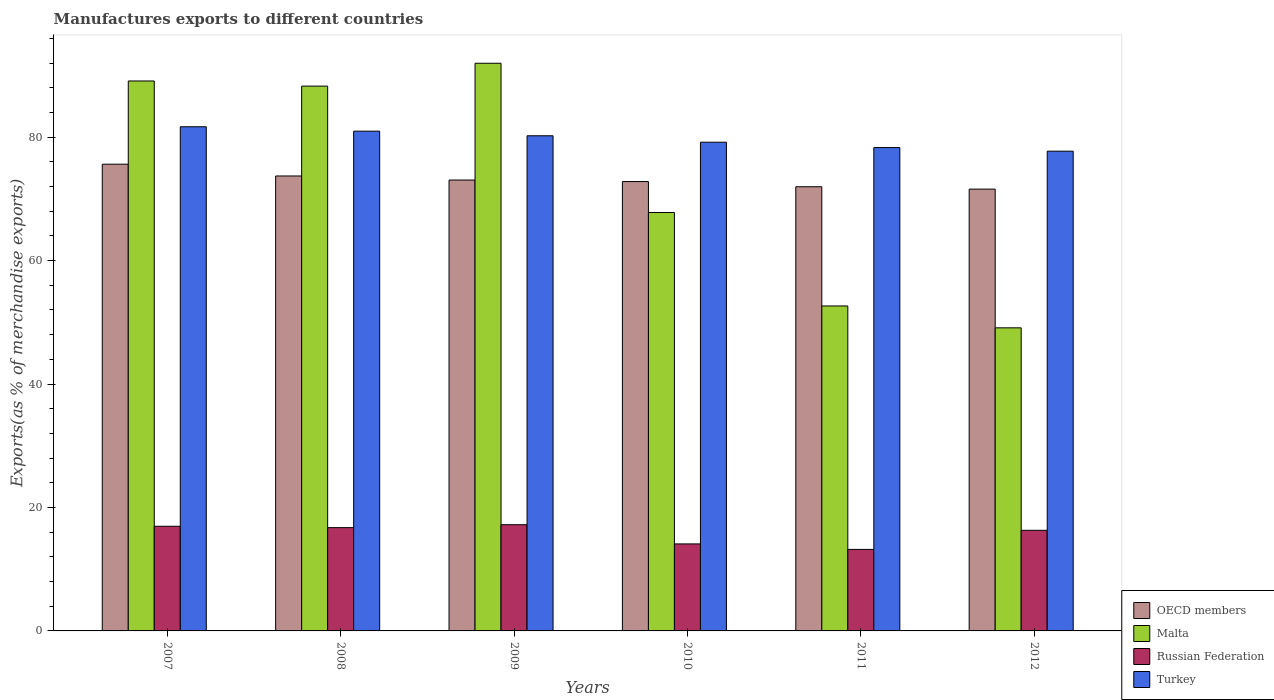How many different coloured bars are there?
Your answer should be very brief. 4. How many bars are there on the 5th tick from the left?
Ensure brevity in your answer.  4. How many bars are there on the 3rd tick from the right?
Provide a short and direct response. 4. In how many cases, is the number of bars for a given year not equal to the number of legend labels?
Provide a succinct answer. 0. What is the percentage of exports to different countries in Malta in 2007?
Ensure brevity in your answer.  89.1. Across all years, what is the maximum percentage of exports to different countries in OECD members?
Offer a very short reply. 75.62. Across all years, what is the minimum percentage of exports to different countries in Russian Federation?
Ensure brevity in your answer.  13.21. In which year was the percentage of exports to different countries in OECD members maximum?
Provide a succinct answer. 2007. In which year was the percentage of exports to different countries in Turkey minimum?
Your response must be concise. 2012. What is the total percentage of exports to different countries in Turkey in the graph?
Make the answer very short. 478.11. What is the difference between the percentage of exports to different countries in Malta in 2008 and that in 2012?
Keep it short and to the point. 39.16. What is the difference between the percentage of exports to different countries in Turkey in 2010 and the percentage of exports to different countries in OECD members in 2009?
Offer a very short reply. 6.13. What is the average percentage of exports to different countries in OECD members per year?
Offer a terse response. 73.12. In the year 2009, what is the difference between the percentage of exports to different countries in Turkey and percentage of exports to different countries in Malta?
Provide a succinct answer. -11.75. What is the ratio of the percentage of exports to different countries in Turkey in 2010 to that in 2012?
Provide a succinct answer. 1.02. Is the percentage of exports to different countries in OECD members in 2010 less than that in 2012?
Give a very brief answer. No. What is the difference between the highest and the second highest percentage of exports to different countries in Russian Federation?
Give a very brief answer. 0.25. What is the difference between the highest and the lowest percentage of exports to different countries in Malta?
Provide a succinct answer. 42.87. In how many years, is the percentage of exports to different countries in Turkey greater than the average percentage of exports to different countries in Turkey taken over all years?
Your response must be concise. 3. Is it the case that in every year, the sum of the percentage of exports to different countries in Turkey and percentage of exports to different countries in Russian Federation is greater than the sum of percentage of exports to different countries in OECD members and percentage of exports to different countries in Malta?
Offer a terse response. No. What does the 4th bar from the left in 2007 represents?
Keep it short and to the point. Turkey. What does the 3rd bar from the right in 2012 represents?
Provide a succinct answer. Malta. Is it the case that in every year, the sum of the percentage of exports to different countries in OECD members and percentage of exports to different countries in Turkey is greater than the percentage of exports to different countries in Malta?
Give a very brief answer. Yes. How many bars are there?
Your answer should be compact. 24. How many years are there in the graph?
Your answer should be very brief. 6. Where does the legend appear in the graph?
Your response must be concise. Bottom right. What is the title of the graph?
Your answer should be compact. Manufactures exports to different countries. Does "Rwanda" appear as one of the legend labels in the graph?
Your answer should be compact. No. What is the label or title of the Y-axis?
Give a very brief answer. Exports(as % of merchandise exports). What is the Exports(as % of merchandise exports) in OECD members in 2007?
Give a very brief answer. 75.62. What is the Exports(as % of merchandise exports) in Malta in 2007?
Provide a short and direct response. 89.1. What is the Exports(as % of merchandise exports) of Russian Federation in 2007?
Offer a terse response. 16.96. What is the Exports(as % of merchandise exports) of Turkey in 2007?
Make the answer very short. 81.69. What is the Exports(as % of merchandise exports) in OECD members in 2008?
Offer a very short reply. 73.71. What is the Exports(as % of merchandise exports) of Malta in 2008?
Your response must be concise. 88.27. What is the Exports(as % of merchandise exports) in Russian Federation in 2008?
Your answer should be compact. 16.74. What is the Exports(as % of merchandise exports) in Turkey in 2008?
Ensure brevity in your answer.  80.97. What is the Exports(as % of merchandise exports) of OECD members in 2009?
Offer a terse response. 73.06. What is the Exports(as % of merchandise exports) of Malta in 2009?
Make the answer very short. 91.98. What is the Exports(as % of merchandise exports) of Russian Federation in 2009?
Keep it short and to the point. 17.21. What is the Exports(as % of merchandise exports) in Turkey in 2009?
Provide a short and direct response. 80.23. What is the Exports(as % of merchandise exports) of OECD members in 2010?
Give a very brief answer. 72.81. What is the Exports(as % of merchandise exports) in Malta in 2010?
Your answer should be very brief. 67.79. What is the Exports(as % of merchandise exports) in Russian Federation in 2010?
Your answer should be very brief. 14.1. What is the Exports(as % of merchandise exports) of Turkey in 2010?
Your answer should be compact. 79.18. What is the Exports(as % of merchandise exports) of OECD members in 2011?
Keep it short and to the point. 71.97. What is the Exports(as % of merchandise exports) in Malta in 2011?
Provide a short and direct response. 52.65. What is the Exports(as % of merchandise exports) of Russian Federation in 2011?
Make the answer very short. 13.21. What is the Exports(as % of merchandise exports) in Turkey in 2011?
Keep it short and to the point. 78.31. What is the Exports(as % of merchandise exports) of OECD members in 2012?
Your response must be concise. 71.58. What is the Exports(as % of merchandise exports) of Malta in 2012?
Provide a short and direct response. 49.11. What is the Exports(as % of merchandise exports) of Russian Federation in 2012?
Keep it short and to the point. 16.3. What is the Exports(as % of merchandise exports) in Turkey in 2012?
Make the answer very short. 77.73. Across all years, what is the maximum Exports(as % of merchandise exports) in OECD members?
Make the answer very short. 75.62. Across all years, what is the maximum Exports(as % of merchandise exports) of Malta?
Provide a succinct answer. 91.98. Across all years, what is the maximum Exports(as % of merchandise exports) of Russian Federation?
Make the answer very short. 17.21. Across all years, what is the maximum Exports(as % of merchandise exports) of Turkey?
Make the answer very short. 81.69. Across all years, what is the minimum Exports(as % of merchandise exports) in OECD members?
Your answer should be compact. 71.58. Across all years, what is the minimum Exports(as % of merchandise exports) of Malta?
Keep it short and to the point. 49.11. Across all years, what is the minimum Exports(as % of merchandise exports) in Russian Federation?
Give a very brief answer. 13.21. Across all years, what is the minimum Exports(as % of merchandise exports) in Turkey?
Ensure brevity in your answer.  77.73. What is the total Exports(as % of merchandise exports) of OECD members in the graph?
Your answer should be very brief. 438.75. What is the total Exports(as % of merchandise exports) of Malta in the graph?
Offer a very short reply. 438.91. What is the total Exports(as % of merchandise exports) of Russian Federation in the graph?
Offer a very short reply. 94.51. What is the total Exports(as % of merchandise exports) in Turkey in the graph?
Keep it short and to the point. 478.11. What is the difference between the Exports(as % of merchandise exports) of OECD members in 2007 and that in 2008?
Your answer should be compact. 1.91. What is the difference between the Exports(as % of merchandise exports) in Malta in 2007 and that in 2008?
Ensure brevity in your answer.  0.83. What is the difference between the Exports(as % of merchandise exports) of Russian Federation in 2007 and that in 2008?
Your response must be concise. 0.22. What is the difference between the Exports(as % of merchandise exports) in Turkey in 2007 and that in 2008?
Your answer should be compact. 0.71. What is the difference between the Exports(as % of merchandise exports) in OECD members in 2007 and that in 2009?
Provide a succinct answer. 2.57. What is the difference between the Exports(as % of merchandise exports) of Malta in 2007 and that in 2009?
Offer a terse response. -2.87. What is the difference between the Exports(as % of merchandise exports) in Russian Federation in 2007 and that in 2009?
Keep it short and to the point. -0.25. What is the difference between the Exports(as % of merchandise exports) of Turkey in 2007 and that in 2009?
Make the answer very short. 1.46. What is the difference between the Exports(as % of merchandise exports) in OECD members in 2007 and that in 2010?
Make the answer very short. 2.81. What is the difference between the Exports(as % of merchandise exports) of Malta in 2007 and that in 2010?
Make the answer very short. 21.31. What is the difference between the Exports(as % of merchandise exports) of Russian Federation in 2007 and that in 2010?
Your answer should be very brief. 2.86. What is the difference between the Exports(as % of merchandise exports) in Turkey in 2007 and that in 2010?
Give a very brief answer. 2.5. What is the difference between the Exports(as % of merchandise exports) of OECD members in 2007 and that in 2011?
Make the answer very short. 3.65. What is the difference between the Exports(as % of merchandise exports) of Malta in 2007 and that in 2011?
Ensure brevity in your answer.  36.45. What is the difference between the Exports(as % of merchandise exports) in Russian Federation in 2007 and that in 2011?
Ensure brevity in your answer.  3.75. What is the difference between the Exports(as % of merchandise exports) of Turkey in 2007 and that in 2011?
Your answer should be very brief. 3.37. What is the difference between the Exports(as % of merchandise exports) of OECD members in 2007 and that in 2012?
Keep it short and to the point. 4.04. What is the difference between the Exports(as % of merchandise exports) of Malta in 2007 and that in 2012?
Ensure brevity in your answer.  40. What is the difference between the Exports(as % of merchandise exports) in Russian Federation in 2007 and that in 2012?
Make the answer very short. 0.65. What is the difference between the Exports(as % of merchandise exports) in Turkey in 2007 and that in 2012?
Offer a terse response. 3.96. What is the difference between the Exports(as % of merchandise exports) of OECD members in 2008 and that in 2009?
Provide a succinct answer. 0.66. What is the difference between the Exports(as % of merchandise exports) in Malta in 2008 and that in 2009?
Make the answer very short. -3.7. What is the difference between the Exports(as % of merchandise exports) in Russian Federation in 2008 and that in 2009?
Offer a very short reply. -0.47. What is the difference between the Exports(as % of merchandise exports) in Turkey in 2008 and that in 2009?
Offer a terse response. 0.74. What is the difference between the Exports(as % of merchandise exports) of OECD members in 2008 and that in 2010?
Make the answer very short. 0.9. What is the difference between the Exports(as % of merchandise exports) in Malta in 2008 and that in 2010?
Make the answer very short. 20.48. What is the difference between the Exports(as % of merchandise exports) in Russian Federation in 2008 and that in 2010?
Your answer should be very brief. 2.64. What is the difference between the Exports(as % of merchandise exports) of Turkey in 2008 and that in 2010?
Give a very brief answer. 1.79. What is the difference between the Exports(as % of merchandise exports) of OECD members in 2008 and that in 2011?
Ensure brevity in your answer.  1.74. What is the difference between the Exports(as % of merchandise exports) of Malta in 2008 and that in 2011?
Your answer should be compact. 35.62. What is the difference between the Exports(as % of merchandise exports) in Russian Federation in 2008 and that in 2011?
Keep it short and to the point. 3.53. What is the difference between the Exports(as % of merchandise exports) in Turkey in 2008 and that in 2011?
Give a very brief answer. 2.66. What is the difference between the Exports(as % of merchandise exports) of OECD members in 2008 and that in 2012?
Your answer should be compact. 2.13. What is the difference between the Exports(as % of merchandise exports) in Malta in 2008 and that in 2012?
Make the answer very short. 39.16. What is the difference between the Exports(as % of merchandise exports) of Russian Federation in 2008 and that in 2012?
Keep it short and to the point. 0.43. What is the difference between the Exports(as % of merchandise exports) of Turkey in 2008 and that in 2012?
Provide a short and direct response. 3.24. What is the difference between the Exports(as % of merchandise exports) of OECD members in 2009 and that in 2010?
Your response must be concise. 0.25. What is the difference between the Exports(as % of merchandise exports) in Malta in 2009 and that in 2010?
Make the answer very short. 24.18. What is the difference between the Exports(as % of merchandise exports) in Russian Federation in 2009 and that in 2010?
Provide a short and direct response. 3.11. What is the difference between the Exports(as % of merchandise exports) of Turkey in 2009 and that in 2010?
Make the answer very short. 1.04. What is the difference between the Exports(as % of merchandise exports) in OECD members in 2009 and that in 2011?
Ensure brevity in your answer.  1.09. What is the difference between the Exports(as % of merchandise exports) in Malta in 2009 and that in 2011?
Provide a succinct answer. 39.32. What is the difference between the Exports(as % of merchandise exports) in Russian Federation in 2009 and that in 2011?
Your answer should be very brief. 4. What is the difference between the Exports(as % of merchandise exports) in Turkey in 2009 and that in 2011?
Keep it short and to the point. 1.91. What is the difference between the Exports(as % of merchandise exports) in OECD members in 2009 and that in 2012?
Offer a terse response. 1.47. What is the difference between the Exports(as % of merchandise exports) of Malta in 2009 and that in 2012?
Keep it short and to the point. 42.87. What is the difference between the Exports(as % of merchandise exports) of Russian Federation in 2009 and that in 2012?
Give a very brief answer. 0.91. What is the difference between the Exports(as % of merchandise exports) in Turkey in 2009 and that in 2012?
Provide a succinct answer. 2.5. What is the difference between the Exports(as % of merchandise exports) of OECD members in 2010 and that in 2011?
Keep it short and to the point. 0.84. What is the difference between the Exports(as % of merchandise exports) of Malta in 2010 and that in 2011?
Provide a succinct answer. 15.14. What is the difference between the Exports(as % of merchandise exports) of Russian Federation in 2010 and that in 2011?
Ensure brevity in your answer.  0.89. What is the difference between the Exports(as % of merchandise exports) in Turkey in 2010 and that in 2011?
Keep it short and to the point. 0.87. What is the difference between the Exports(as % of merchandise exports) of OECD members in 2010 and that in 2012?
Offer a terse response. 1.22. What is the difference between the Exports(as % of merchandise exports) of Malta in 2010 and that in 2012?
Your answer should be compact. 18.68. What is the difference between the Exports(as % of merchandise exports) in Russian Federation in 2010 and that in 2012?
Ensure brevity in your answer.  -2.2. What is the difference between the Exports(as % of merchandise exports) in Turkey in 2010 and that in 2012?
Ensure brevity in your answer.  1.45. What is the difference between the Exports(as % of merchandise exports) in OECD members in 2011 and that in 2012?
Your answer should be compact. 0.38. What is the difference between the Exports(as % of merchandise exports) in Malta in 2011 and that in 2012?
Your response must be concise. 3.54. What is the difference between the Exports(as % of merchandise exports) in Russian Federation in 2011 and that in 2012?
Give a very brief answer. -3.1. What is the difference between the Exports(as % of merchandise exports) in Turkey in 2011 and that in 2012?
Your answer should be compact. 0.58. What is the difference between the Exports(as % of merchandise exports) of OECD members in 2007 and the Exports(as % of merchandise exports) of Malta in 2008?
Keep it short and to the point. -12.65. What is the difference between the Exports(as % of merchandise exports) in OECD members in 2007 and the Exports(as % of merchandise exports) in Russian Federation in 2008?
Your answer should be compact. 58.88. What is the difference between the Exports(as % of merchandise exports) of OECD members in 2007 and the Exports(as % of merchandise exports) of Turkey in 2008?
Give a very brief answer. -5.35. What is the difference between the Exports(as % of merchandise exports) of Malta in 2007 and the Exports(as % of merchandise exports) of Russian Federation in 2008?
Your answer should be compact. 72.37. What is the difference between the Exports(as % of merchandise exports) of Malta in 2007 and the Exports(as % of merchandise exports) of Turkey in 2008?
Offer a terse response. 8.13. What is the difference between the Exports(as % of merchandise exports) in Russian Federation in 2007 and the Exports(as % of merchandise exports) in Turkey in 2008?
Your answer should be compact. -64.02. What is the difference between the Exports(as % of merchandise exports) in OECD members in 2007 and the Exports(as % of merchandise exports) in Malta in 2009?
Provide a succinct answer. -16.36. What is the difference between the Exports(as % of merchandise exports) of OECD members in 2007 and the Exports(as % of merchandise exports) of Russian Federation in 2009?
Ensure brevity in your answer.  58.41. What is the difference between the Exports(as % of merchandise exports) in OECD members in 2007 and the Exports(as % of merchandise exports) in Turkey in 2009?
Offer a very short reply. -4.61. What is the difference between the Exports(as % of merchandise exports) of Malta in 2007 and the Exports(as % of merchandise exports) of Russian Federation in 2009?
Provide a succinct answer. 71.9. What is the difference between the Exports(as % of merchandise exports) of Malta in 2007 and the Exports(as % of merchandise exports) of Turkey in 2009?
Your answer should be very brief. 8.88. What is the difference between the Exports(as % of merchandise exports) of Russian Federation in 2007 and the Exports(as % of merchandise exports) of Turkey in 2009?
Your answer should be very brief. -63.27. What is the difference between the Exports(as % of merchandise exports) in OECD members in 2007 and the Exports(as % of merchandise exports) in Malta in 2010?
Your answer should be compact. 7.83. What is the difference between the Exports(as % of merchandise exports) in OECD members in 2007 and the Exports(as % of merchandise exports) in Russian Federation in 2010?
Your response must be concise. 61.52. What is the difference between the Exports(as % of merchandise exports) in OECD members in 2007 and the Exports(as % of merchandise exports) in Turkey in 2010?
Provide a succinct answer. -3.56. What is the difference between the Exports(as % of merchandise exports) in Malta in 2007 and the Exports(as % of merchandise exports) in Russian Federation in 2010?
Ensure brevity in your answer.  75.01. What is the difference between the Exports(as % of merchandise exports) in Malta in 2007 and the Exports(as % of merchandise exports) in Turkey in 2010?
Provide a succinct answer. 9.92. What is the difference between the Exports(as % of merchandise exports) of Russian Federation in 2007 and the Exports(as % of merchandise exports) of Turkey in 2010?
Offer a very short reply. -62.23. What is the difference between the Exports(as % of merchandise exports) in OECD members in 2007 and the Exports(as % of merchandise exports) in Malta in 2011?
Offer a terse response. 22.97. What is the difference between the Exports(as % of merchandise exports) in OECD members in 2007 and the Exports(as % of merchandise exports) in Russian Federation in 2011?
Your answer should be compact. 62.41. What is the difference between the Exports(as % of merchandise exports) in OECD members in 2007 and the Exports(as % of merchandise exports) in Turkey in 2011?
Keep it short and to the point. -2.69. What is the difference between the Exports(as % of merchandise exports) in Malta in 2007 and the Exports(as % of merchandise exports) in Russian Federation in 2011?
Your response must be concise. 75.9. What is the difference between the Exports(as % of merchandise exports) of Malta in 2007 and the Exports(as % of merchandise exports) of Turkey in 2011?
Your answer should be very brief. 10.79. What is the difference between the Exports(as % of merchandise exports) of Russian Federation in 2007 and the Exports(as % of merchandise exports) of Turkey in 2011?
Provide a short and direct response. -61.36. What is the difference between the Exports(as % of merchandise exports) in OECD members in 2007 and the Exports(as % of merchandise exports) in Malta in 2012?
Provide a short and direct response. 26.51. What is the difference between the Exports(as % of merchandise exports) of OECD members in 2007 and the Exports(as % of merchandise exports) of Russian Federation in 2012?
Offer a terse response. 59.32. What is the difference between the Exports(as % of merchandise exports) in OECD members in 2007 and the Exports(as % of merchandise exports) in Turkey in 2012?
Give a very brief answer. -2.11. What is the difference between the Exports(as % of merchandise exports) in Malta in 2007 and the Exports(as % of merchandise exports) in Russian Federation in 2012?
Your answer should be compact. 72.8. What is the difference between the Exports(as % of merchandise exports) of Malta in 2007 and the Exports(as % of merchandise exports) of Turkey in 2012?
Offer a very short reply. 11.37. What is the difference between the Exports(as % of merchandise exports) of Russian Federation in 2007 and the Exports(as % of merchandise exports) of Turkey in 2012?
Provide a short and direct response. -60.77. What is the difference between the Exports(as % of merchandise exports) of OECD members in 2008 and the Exports(as % of merchandise exports) of Malta in 2009?
Ensure brevity in your answer.  -18.26. What is the difference between the Exports(as % of merchandise exports) of OECD members in 2008 and the Exports(as % of merchandise exports) of Russian Federation in 2009?
Your answer should be compact. 56.5. What is the difference between the Exports(as % of merchandise exports) of OECD members in 2008 and the Exports(as % of merchandise exports) of Turkey in 2009?
Provide a succinct answer. -6.52. What is the difference between the Exports(as % of merchandise exports) in Malta in 2008 and the Exports(as % of merchandise exports) in Russian Federation in 2009?
Offer a very short reply. 71.06. What is the difference between the Exports(as % of merchandise exports) in Malta in 2008 and the Exports(as % of merchandise exports) in Turkey in 2009?
Your answer should be compact. 8.04. What is the difference between the Exports(as % of merchandise exports) of Russian Federation in 2008 and the Exports(as % of merchandise exports) of Turkey in 2009?
Keep it short and to the point. -63.49. What is the difference between the Exports(as % of merchandise exports) of OECD members in 2008 and the Exports(as % of merchandise exports) of Malta in 2010?
Your answer should be compact. 5.92. What is the difference between the Exports(as % of merchandise exports) of OECD members in 2008 and the Exports(as % of merchandise exports) of Russian Federation in 2010?
Provide a succinct answer. 59.61. What is the difference between the Exports(as % of merchandise exports) in OECD members in 2008 and the Exports(as % of merchandise exports) in Turkey in 2010?
Your answer should be compact. -5.47. What is the difference between the Exports(as % of merchandise exports) of Malta in 2008 and the Exports(as % of merchandise exports) of Russian Federation in 2010?
Your response must be concise. 74.17. What is the difference between the Exports(as % of merchandise exports) in Malta in 2008 and the Exports(as % of merchandise exports) in Turkey in 2010?
Your response must be concise. 9.09. What is the difference between the Exports(as % of merchandise exports) in Russian Federation in 2008 and the Exports(as % of merchandise exports) in Turkey in 2010?
Give a very brief answer. -62.45. What is the difference between the Exports(as % of merchandise exports) in OECD members in 2008 and the Exports(as % of merchandise exports) in Malta in 2011?
Provide a short and direct response. 21.06. What is the difference between the Exports(as % of merchandise exports) of OECD members in 2008 and the Exports(as % of merchandise exports) of Russian Federation in 2011?
Offer a very short reply. 60.5. What is the difference between the Exports(as % of merchandise exports) in OECD members in 2008 and the Exports(as % of merchandise exports) in Turkey in 2011?
Offer a very short reply. -4.6. What is the difference between the Exports(as % of merchandise exports) in Malta in 2008 and the Exports(as % of merchandise exports) in Russian Federation in 2011?
Give a very brief answer. 75.06. What is the difference between the Exports(as % of merchandise exports) in Malta in 2008 and the Exports(as % of merchandise exports) in Turkey in 2011?
Ensure brevity in your answer.  9.96. What is the difference between the Exports(as % of merchandise exports) of Russian Federation in 2008 and the Exports(as % of merchandise exports) of Turkey in 2011?
Keep it short and to the point. -61.58. What is the difference between the Exports(as % of merchandise exports) of OECD members in 2008 and the Exports(as % of merchandise exports) of Malta in 2012?
Provide a short and direct response. 24.6. What is the difference between the Exports(as % of merchandise exports) of OECD members in 2008 and the Exports(as % of merchandise exports) of Russian Federation in 2012?
Your answer should be compact. 57.41. What is the difference between the Exports(as % of merchandise exports) in OECD members in 2008 and the Exports(as % of merchandise exports) in Turkey in 2012?
Ensure brevity in your answer.  -4.02. What is the difference between the Exports(as % of merchandise exports) of Malta in 2008 and the Exports(as % of merchandise exports) of Russian Federation in 2012?
Offer a very short reply. 71.97. What is the difference between the Exports(as % of merchandise exports) of Malta in 2008 and the Exports(as % of merchandise exports) of Turkey in 2012?
Your answer should be very brief. 10.54. What is the difference between the Exports(as % of merchandise exports) of Russian Federation in 2008 and the Exports(as % of merchandise exports) of Turkey in 2012?
Ensure brevity in your answer.  -60.99. What is the difference between the Exports(as % of merchandise exports) in OECD members in 2009 and the Exports(as % of merchandise exports) in Malta in 2010?
Your answer should be very brief. 5.26. What is the difference between the Exports(as % of merchandise exports) of OECD members in 2009 and the Exports(as % of merchandise exports) of Russian Federation in 2010?
Provide a succinct answer. 58.96. What is the difference between the Exports(as % of merchandise exports) in OECD members in 2009 and the Exports(as % of merchandise exports) in Turkey in 2010?
Make the answer very short. -6.13. What is the difference between the Exports(as % of merchandise exports) in Malta in 2009 and the Exports(as % of merchandise exports) in Russian Federation in 2010?
Give a very brief answer. 77.88. What is the difference between the Exports(as % of merchandise exports) of Malta in 2009 and the Exports(as % of merchandise exports) of Turkey in 2010?
Offer a very short reply. 12.79. What is the difference between the Exports(as % of merchandise exports) of Russian Federation in 2009 and the Exports(as % of merchandise exports) of Turkey in 2010?
Your answer should be compact. -61.97. What is the difference between the Exports(as % of merchandise exports) of OECD members in 2009 and the Exports(as % of merchandise exports) of Malta in 2011?
Ensure brevity in your answer.  20.4. What is the difference between the Exports(as % of merchandise exports) of OECD members in 2009 and the Exports(as % of merchandise exports) of Russian Federation in 2011?
Offer a terse response. 59.85. What is the difference between the Exports(as % of merchandise exports) in OECD members in 2009 and the Exports(as % of merchandise exports) in Turkey in 2011?
Your response must be concise. -5.26. What is the difference between the Exports(as % of merchandise exports) of Malta in 2009 and the Exports(as % of merchandise exports) of Russian Federation in 2011?
Ensure brevity in your answer.  78.77. What is the difference between the Exports(as % of merchandise exports) of Malta in 2009 and the Exports(as % of merchandise exports) of Turkey in 2011?
Offer a very short reply. 13.66. What is the difference between the Exports(as % of merchandise exports) of Russian Federation in 2009 and the Exports(as % of merchandise exports) of Turkey in 2011?
Offer a terse response. -61.11. What is the difference between the Exports(as % of merchandise exports) in OECD members in 2009 and the Exports(as % of merchandise exports) in Malta in 2012?
Provide a succinct answer. 23.95. What is the difference between the Exports(as % of merchandise exports) in OECD members in 2009 and the Exports(as % of merchandise exports) in Russian Federation in 2012?
Give a very brief answer. 56.75. What is the difference between the Exports(as % of merchandise exports) in OECD members in 2009 and the Exports(as % of merchandise exports) in Turkey in 2012?
Make the answer very short. -4.68. What is the difference between the Exports(as % of merchandise exports) of Malta in 2009 and the Exports(as % of merchandise exports) of Russian Federation in 2012?
Ensure brevity in your answer.  75.67. What is the difference between the Exports(as % of merchandise exports) of Malta in 2009 and the Exports(as % of merchandise exports) of Turkey in 2012?
Keep it short and to the point. 14.25. What is the difference between the Exports(as % of merchandise exports) in Russian Federation in 2009 and the Exports(as % of merchandise exports) in Turkey in 2012?
Your answer should be very brief. -60.52. What is the difference between the Exports(as % of merchandise exports) in OECD members in 2010 and the Exports(as % of merchandise exports) in Malta in 2011?
Make the answer very short. 20.16. What is the difference between the Exports(as % of merchandise exports) of OECD members in 2010 and the Exports(as % of merchandise exports) of Russian Federation in 2011?
Your response must be concise. 59.6. What is the difference between the Exports(as % of merchandise exports) in OECD members in 2010 and the Exports(as % of merchandise exports) in Turkey in 2011?
Make the answer very short. -5.51. What is the difference between the Exports(as % of merchandise exports) in Malta in 2010 and the Exports(as % of merchandise exports) in Russian Federation in 2011?
Provide a short and direct response. 54.59. What is the difference between the Exports(as % of merchandise exports) of Malta in 2010 and the Exports(as % of merchandise exports) of Turkey in 2011?
Offer a very short reply. -10.52. What is the difference between the Exports(as % of merchandise exports) in Russian Federation in 2010 and the Exports(as % of merchandise exports) in Turkey in 2011?
Provide a succinct answer. -64.22. What is the difference between the Exports(as % of merchandise exports) of OECD members in 2010 and the Exports(as % of merchandise exports) of Malta in 2012?
Offer a terse response. 23.7. What is the difference between the Exports(as % of merchandise exports) of OECD members in 2010 and the Exports(as % of merchandise exports) of Russian Federation in 2012?
Ensure brevity in your answer.  56.51. What is the difference between the Exports(as % of merchandise exports) of OECD members in 2010 and the Exports(as % of merchandise exports) of Turkey in 2012?
Provide a short and direct response. -4.92. What is the difference between the Exports(as % of merchandise exports) in Malta in 2010 and the Exports(as % of merchandise exports) in Russian Federation in 2012?
Your answer should be very brief. 51.49. What is the difference between the Exports(as % of merchandise exports) of Malta in 2010 and the Exports(as % of merchandise exports) of Turkey in 2012?
Offer a very short reply. -9.94. What is the difference between the Exports(as % of merchandise exports) in Russian Federation in 2010 and the Exports(as % of merchandise exports) in Turkey in 2012?
Offer a very short reply. -63.63. What is the difference between the Exports(as % of merchandise exports) of OECD members in 2011 and the Exports(as % of merchandise exports) of Malta in 2012?
Provide a short and direct response. 22.86. What is the difference between the Exports(as % of merchandise exports) in OECD members in 2011 and the Exports(as % of merchandise exports) in Russian Federation in 2012?
Provide a succinct answer. 55.67. What is the difference between the Exports(as % of merchandise exports) in OECD members in 2011 and the Exports(as % of merchandise exports) in Turkey in 2012?
Make the answer very short. -5.76. What is the difference between the Exports(as % of merchandise exports) of Malta in 2011 and the Exports(as % of merchandise exports) of Russian Federation in 2012?
Offer a very short reply. 36.35. What is the difference between the Exports(as % of merchandise exports) of Malta in 2011 and the Exports(as % of merchandise exports) of Turkey in 2012?
Provide a short and direct response. -25.08. What is the difference between the Exports(as % of merchandise exports) in Russian Federation in 2011 and the Exports(as % of merchandise exports) in Turkey in 2012?
Ensure brevity in your answer.  -64.52. What is the average Exports(as % of merchandise exports) in OECD members per year?
Provide a short and direct response. 73.12. What is the average Exports(as % of merchandise exports) in Malta per year?
Your response must be concise. 73.15. What is the average Exports(as % of merchandise exports) in Russian Federation per year?
Provide a succinct answer. 15.75. What is the average Exports(as % of merchandise exports) of Turkey per year?
Offer a terse response. 79.69. In the year 2007, what is the difference between the Exports(as % of merchandise exports) of OECD members and Exports(as % of merchandise exports) of Malta?
Your response must be concise. -13.48. In the year 2007, what is the difference between the Exports(as % of merchandise exports) of OECD members and Exports(as % of merchandise exports) of Russian Federation?
Give a very brief answer. 58.66. In the year 2007, what is the difference between the Exports(as % of merchandise exports) of OECD members and Exports(as % of merchandise exports) of Turkey?
Make the answer very short. -6.07. In the year 2007, what is the difference between the Exports(as % of merchandise exports) in Malta and Exports(as % of merchandise exports) in Russian Federation?
Offer a very short reply. 72.15. In the year 2007, what is the difference between the Exports(as % of merchandise exports) of Malta and Exports(as % of merchandise exports) of Turkey?
Make the answer very short. 7.42. In the year 2007, what is the difference between the Exports(as % of merchandise exports) in Russian Federation and Exports(as % of merchandise exports) in Turkey?
Your answer should be very brief. -64.73. In the year 2008, what is the difference between the Exports(as % of merchandise exports) in OECD members and Exports(as % of merchandise exports) in Malta?
Your answer should be very brief. -14.56. In the year 2008, what is the difference between the Exports(as % of merchandise exports) of OECD members and Exports(as % of merchandise exports) of Russian Federation?
Your answer should be very brief. 56.98. In the year 2008, what is the difference between the Exports(as % of merchandise exports) in OECD members and Exports(as % of merchandise exports) in Turkey?
Provide a short and direct response. -7.26. In the year 2008, what is the difference between the Exports(as % of merchandise exports) in Malta and Exports(as % of merchandise exports) in Russian Federation?
Your response must be concise. 71.54. In the year 2008, what is the difference between the Exports(as % of merchandise exports) in Malta and Exports(as % of merchandise exports) in Turkey?
Provide a succinct answer. 7.3. In the year 2008, what is the difference between the Exports(as % of merchandise exports) of Russian Federation and Exports(as % of merchandise exports) of Turkey?
Ensure brevity in your answer.  -64.24. In the year 2009, what is the difference between the Exports(as % of merchandise exports) in OECD members and Exports(as % of merchandise exports) in Malta?
Your answer should be compact. -18.92. In the year 2009, what is the difference between the Exports(as % of merchandise exports) in OECD members and Exports(as % of merchandise exports) in Russian Federation?
Make the answer very short. 55.85. In the year 2009, what is the difference between the Exports(as % of merchandise exports) in OECD members and Exports(as % of merchandise exports) in Turkey?
Provide a short and direct response. -7.17. In the year 2009, what is the difference between the Exports(as % of merchandise exports) of Malta and Exports(as % of merchandise exports) of Russian Federation?
Ensure brevity in your answer.  74.77. In the year 2009, what is the difference between the Exports(as % of merchandise exports) of Malta and Exports(as % of merchandise exports) of Turkey?
Your response must be concise. 11.75. In the year 2009, what is the difference between the Exports(as % of merchandise exports) in Russian Federation and Exports(as % of merchandise exports) in Turkey?
Ensure brevity in your answer.  -63.02. In the year 2010, what is the difference between the Exports(as % of merchandise exports) of OECD members and Exports(as % of merchandise exports) of Malta?
Offer a very short reply. 5.01. In the year 2010, what is the difference between the Exports(as % of merchandise exports) in OECD members and Exports(as % of merchandise exports) in Russian Federation?
Your response must be concise. 58.71. In the year 2010, what is the difference between the Exports(as % of merchandise exports) of OECD members and Exports(as % of merchandise exports) of Turkey?
Offer a terse response. -6.38. In the year 2010, what is the difference between the Exports(as % of merchandise exports) of Malta and Exports(as % of merchandise exports) of Russian Federation?
Ensure brevity in your answer.  53.7. In the year 2010, what is the difference between the Exports(as % of merchandise exports) of Malta and Exports(as % of merchandise exports) of Turkey?
Make the answer very short. -11.39. In the year 2010, what is the difference between the Exports(as % of merchandise exports) of Russian Federation and Exports(as % of merchandise exports) of Turkey?
Provide a short and direct response. -65.09. In the year 2011, what is the difference between the Exports(as % of merchandise exports) of OECD members and Exports(as % of merchandise exports) of Malta?
Offer a terse response. 19.32. In the year 2011, what is the difference between the Exports(as % of merchandise exports) in OECD members and Exports(as % of merchandise exports) in Russian Federation?
Your response must be concise. 58.76. In the year 2011, what is the difference between the Exports(as % of merchandise exports) of OECD members and Exports(as % of merchandise exports) of Turkey?
Ensure brevity in your answer.  -6.35. In the year 2011, what is the difference between the Exports(as % of merchandise exports) of Malta and Exports(as % of merchandise exports) of Russian Federation?
Your answer should be compact. 39.44. In the year 2011, what is the difference between the Exports(as % of merchandise exports) of Malta and Exports(as % of merchandise exports) of Turkey?
Offer a terse response. -25.66. In the year 2011, what is the difference between the Exports(as % of merchandise exports) of Russian Federation and Exports(as % of merchandise exports) of Turkey?
Ensure brevity in your answer.  -65.11. In the year 2012, what is the difference between the Exports(as % of merchandise exports) in OECD members and Exports(as % of merchandise exports) in Malta?
Your answer should be compact. 22.48. In the year 2012, what is the difference between the Exports(as % of merchandise exports) in OECD members and Exports(as % of merchandise exports) in Russian Federation?
Provide a short and direct response. 55.28. In the year 2012, what is the difference between the Exports(as % of merchandise exports) in OECD members and Exports(as % of merchandise exports) in Turkey?
Keep it short and to the point. -6.15. In the year 2012, what is the difference between the Exports(as % of merchandise exports) in Malta and Exports(as % of merchandise exports) in Russian Federation?
Your answer should be compact. 32.81. In the year 2012, what is the difference between the Exports(as % of merchandise exports) of Malta and Exports(as % of merchandise exports) of Turkey?
Your answer should be very brief. -28.62. In the year 2012, what is the difference between the Exports(as % of merchandise exports) in Russian Federation and Exports(as % of merchandise exports) in Turkey?
Your response must be concise. -61.43. What is the ratio of the Exports(as % of merchandise exports) of OECD members in 2007 to that in 2008?
Your answer should be very brief. 1.03. What is the ratio of the Exports(as % of merchandise exports) of Malta in 2007 to that in 2008?
Provide a short and direct response. 1.01. What is the ratio of the Exports(as % of merchandise exports) of Russian Federation in 2007 to that in 2008?
Provide a succinct answer. 1.01. What is the ratio of the Exports(as % of merchandise exports) in Turkey in 2007 to that in 2008?
Make the answer very short. 1.01. What is the ratio of the Exports(as % of merchandise exports) in OECD members in 2007 to that in 2009?
Provide a succinct answer. 1.04. What is the ratio of the Exports(as % of merchandise exports) of Malta in 2007 to that in 2009?
Give a very brief answer. 0.97. What is the ratio of the Exports(as % of merchandise exports) of Russian Federation in 2007 to that in 2009?
Keep it short and to the point. 0.99. What is the ratio of the Exports(as % of merchandise exports) in Turkey in 2007 to that in 2009?
Make the answer very short. 1.02. What is the ratio of the Exports(as % of merchandise exports) of OECD members in 2007 to that in 2010?
Offer a terse response. 1.04. What is the ratio of the Exports(as % of merchandise exports) of Malta in 2007 to that in 2010?
Provide a succinct answer. 1.31. What is the ratio of the Exports(as % of merchandise exports) in Russian Federation in 2007 to that in 2010?
Offer a terse response. 1.2. What is the ratio of the Exports(as % of merchandise exports) in Turkey in 2007 to that in 2010?
Offer a very short reply. 1.03. What is the ratio of the Exports(as % of merchandise exports) of OECD members in 2007 to that in 2011?
Offer a terse response. 1.05. What is the ratio of the Exports(as % of merchandise exports) of Malta in 2007 to that in 2011?
Offer a terse response. 1.69. What is the ratio of the Exports(as % of merchandise exports) of Russian Federation in 2007 to that in 2011?
Offer a terse response. 1.28. What is the ratio of the Exports(as % of merchandise exports) in Turkey in 2007 to that in 2011?
Ensure brevity in your answer.  1.04. What is the ratio of the Exports(as % of merchandise exports) in OECD members in 2007 to that in 2012?
Offer a terse response. 1.06. What is the ratio of the Exports(as % of merchandise exports) in Malta in 2007 to that in 2012?
Give a very brief answer. 1.81. What is the ratio of the Exports(as % of merchandise exports) of Russian Federation in 2007 to that in 2012?
Your answer should be very brief. 1.04. What is the ratio of the Exports(as % of merchandise exports) in Turkey in 2007 to that in 2012?
Your response must be concise. 1.05. What is the ratio of the Exports(as % of merchandise exports) of OECD members in 2008 to that in 2009?
Keep it short and to the point. 1.01. What is the ratio of the Exports(as % of merchandise exports) of Malta in 2008 to that in 2009?
Give a very brief answer. 0.96. What is the ratio of the Exports(as % of merchandise exports) of Russian Federation in 2008 to that in 2009?
Ensure brevity in your answer.  0.97. What is the ratio of the Exports(as % of merchandise exports) in Turkey in 2008 to that in 2009?
Ensure brevity in your answer.  1.01. What is the ratio of the Exports(as % of merchandise exports) in OECD members in 2008 to that in 2010?
Your response must be concise. 1.01. What is the ratio of the Exports(as % of merchandise exports) of Malta in 2008 to that in 2010?
Your answer should be compact. 1.3. What is the ratio of the Exports(as % of merchandise exports) in Russian Federation in 2008 to that in 2010?
Your response must be concise. 1.19. What is the ratio of the Exports(as % of merchandise exports) of Turkey in 2008 to that in 2010?
Your response must be concise. 1.02. What is the ratio of the Exports(as % of merchandise exports) in OECD members in 2008 to that in 2011?
Offer a terse response. 1.02. What is the ratio of the Exports(as % of merchandise exports) in Malta in 2008 to that in 2011?
Provide a succinct answer. 1.68. What is the ratio of the Exports(as % of merchandise exports) of Russian Federation in 2008 to that in 2011?
Ensure brevity in your answer.  1.27. What is the ratio of the Exports(as % of merchandise exports) in Turkey in 2008 to that in 2011?
Give a very brief answer. 1.03. What is the ratio of the Exports(as % of merchandise exports) in OECD members in 2008 to that in 2012?
Provide a short and direct response. 1.03. What is the ratio of the Exports(as % of merchandise exports) in Malta in 2008 to that in 2012?
Your answer should be compact. 1.8. What is the ratio of the Exports(as % of merchandise exports) of Russian Federation in 2008 to that in 2012?
Ensure brevity in your answer.  1.03. What is the ratio of the Exports(as % of merchandise exports) of Turkey in 2008 to that in 2012?
Make the answer very short. 1.04. What is the ratio of the Exports(as % of merchandise exports) in OECD members in 2009 to that in 2010?
Keep it short and to the point. 1. What is the ratio of the Exports(as % of merchandise exports) of Malta in 2009 to that in 2010?
Your answer should be very brief. 1.36. What is the ratio of the Exports(as % of merchandise exports) of Russian Federation in 2009 to that in 2010?
Give a very brief answer. 1.22. What is the ratio of the Exports(as % of merchandise exports) of Turkey in 2009 to that in 2010?
Your answer should be compact. 1.01. What is the ratio of the Exports(as % of merchandise exports) of OECD members in 2009 to that in 2011?
Keep it short and to the point. 1.02. What is the ratio of the Exports(as % of merchandise exports) of Malta in 2009 to that in 2011?
Ensure brevity in your answer.  1.75. What is the ratio of the Exports(as % of merchandise exports) in Russian Federation in 2009 to that in 2011?
Offer a very short reply. 1.3. What is the ratio of the Exports(as % of merchandise exports) of Turkey in 2009 to that in 2011?
Your answer should be very brief. 1.02. What is the ratio of the Exports(as % of merchandise exports) in OECD members in 2009 to that in 2012?
Provide a succinct answer. 1.02. What is the ratio of the Exports(as % of merchandise exports) in Malta in 2009 to that in 2012?
Keep it short and to the point. 1.87. What is the ratio of the Exports(as % of merchandise exports) in Russian Federation in 2009 to that in 2012?
Offer a terse response. 1.06. What is the ratio of the Exports(as % of merchandise exports) in Turkey in 2009 to that in 2012?
Make the answer very short. 1.03. What is the ratio of the Exports(as % of merchandise exports) in OECD members in 2010 to that in 2011?
Provide a short and direct response. 1.01. What is the ratio of the Exports(as % of merchandise exports) in Malta in 2010 to that in 2011?
Offer a terse response. 1.29. What is the ratio of the Exports(as % of merchandise exports) in Russian Federation in 2010 to that in 2011?
Provide a short and direct response. 1.07. What is the ratio of the Exports(as % of merchandise exports) in Turkey in 2010 to that in 2011?
Your answer should be compact. 1.01. What is the ratio of the Exports(as % of merchandise exports) of OECD members in 2010 to that in 2012?
Make the answer very short. 1.02. What is the ratio of the Exports(as % of merchandise exports) in Malta in 2010 to that in 2012?
Your answer should be very brief. 1.38. What is the ratio of the Exports(as % of merchandise exports) in Russian Federation in 2010 to that in 2012?
Offer a terse response. 0.86. What is the ratio of the Exports(as % of merchandise exports) of Turkey in 2010 to that in 2012?
Offer a very short reply. 1.02. What is the ratio of the Exports(as % of merchandise exports) in OECD members in 2011 to that in 2012?
Ensure brevity in your answer.  1.01. What is the ratio of the Exports(as % of merchandise exports) of Malta in 2011 to that in 2012?
Offer a terse response. 1.07. What is the ratio of the Exports(as % of merchandise exports) in Russian Federation in 2011 to that in 2012?
Offer a very short reply. 0.81. What is the ratio of the Exports(as % of merchandise exports) in Turkey in 2011 to that in 2012?
Your response must be concise. 1.01. What is the difference between the highest and the second highest Exports(as % of merchandise exports) of OECD members?
Provide a succinct answer. 1.91. What is the difference between the highest and the second highest Exports(as % of merchandise exports) of Malta?
Your answer should be compact. 2.87. What is the difference between the highest and the second highest Exports(as % of merchandise exports) in Russian Federation?
Give a very brief answer. 0.25. What is the difference between the highest and the second highest Exports(as % of merchandise exports) of Turkey?
Make the answer very short. 0.71. What is the difference between the highest and the lowest Exports(as % of merchandise exports) in OECD members?
Provide a short and direct response. 4.04. What is the difference between the highest and the lowest Exports(as % of merchandise exports) in Malta?
Provide a succinct answer. 42.87. What is the difference between the highest and the lowest Exports(as % of merchandise exports) of Russian Federation?
Provide a succinct answer. 4. What is the difference between the highest and the lowest Exports(as % of merchandise exports) of Turkey?
Your response must be concise. 3.96. 